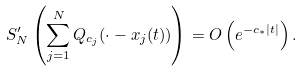Convert formula to latex. <formula><loc_0><loc_0><loc_500><loc_500>S _ { N } ^ { \prime } \left ( \sum _ { j = 1 } ^ { N } Q _ { c _ { j } } ( \cdot - x _ { j } ( t ) ) \right ) = O \left ( e ^ { - c _ { * } | t | } \right ) .</formula> 